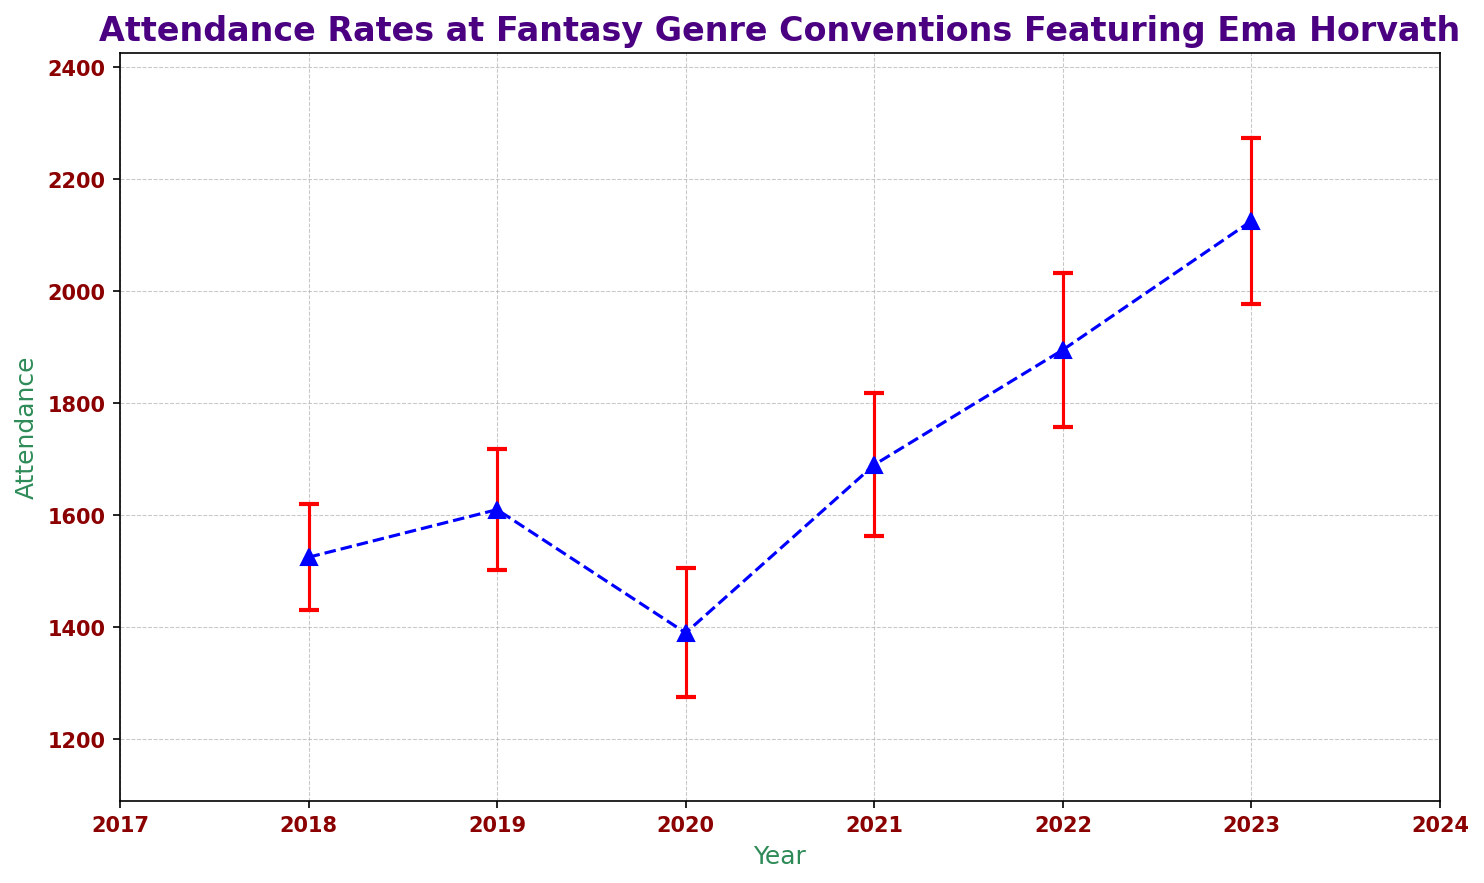Which year had the highest average attendance? The plot shows the average attendance for each year with error bars. By looking at the peak attendance value, the year with the highest average attendance is 2023.
Answer: 2023 What is the average attendance in 2020? Average attendance is calculated by taking data points for 2020, which are 1400 and 1380, and then averaging them. (1400 + 1380) / 2 = 1390.
Answer: 1390 Which year had the largest error margin? The error margin is indicated by the length of the error bars. By comparing the bars, the longest error margin bar is in 2023.
Answer: 2023 How did the attendance trend change from 2020 to 2021? From 2020 to 2021, the average attendance increased. 2020 had an average of 1390, and it increased to around 1690 in 2021.
Answer: Increased What was the year-to-year fluctuation between 2019 and 2020 in attendance? Attendance in 2019 was approximately 1610 and decreased to about 1390 in 2020. The fluctuation can be calculated as 1610 - 1390 = 220.
Answer: 220 Is there a noticeable trend in attendance from 2018 to 2023? Observing the overall pattern, attendance shows an increasing trend from 2018 to 2023, with a dip in 2020.
Answer: Increasing trend Which year had a higher attendance, 2018 or 2019? Comparing the average attendance values, 2018 had around 1525, while 2019 had around 1610. Therefore, 2019 had higher attendance.
Answer: 2019 Compare the error margins between 2018 and 2022. Which year had smaller error margins? In 2018, the error margin is around 95, and in 2022, it is around 137. Thus, 2018 had smaller error margins.
Answer: 2018 